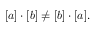Convert formula to latex. <formula><loc_0><loc_0><loc_500><loc_500>[ a ] \cdot [ b ] \neq [ b ] \cdot [ a ] .</formula> 